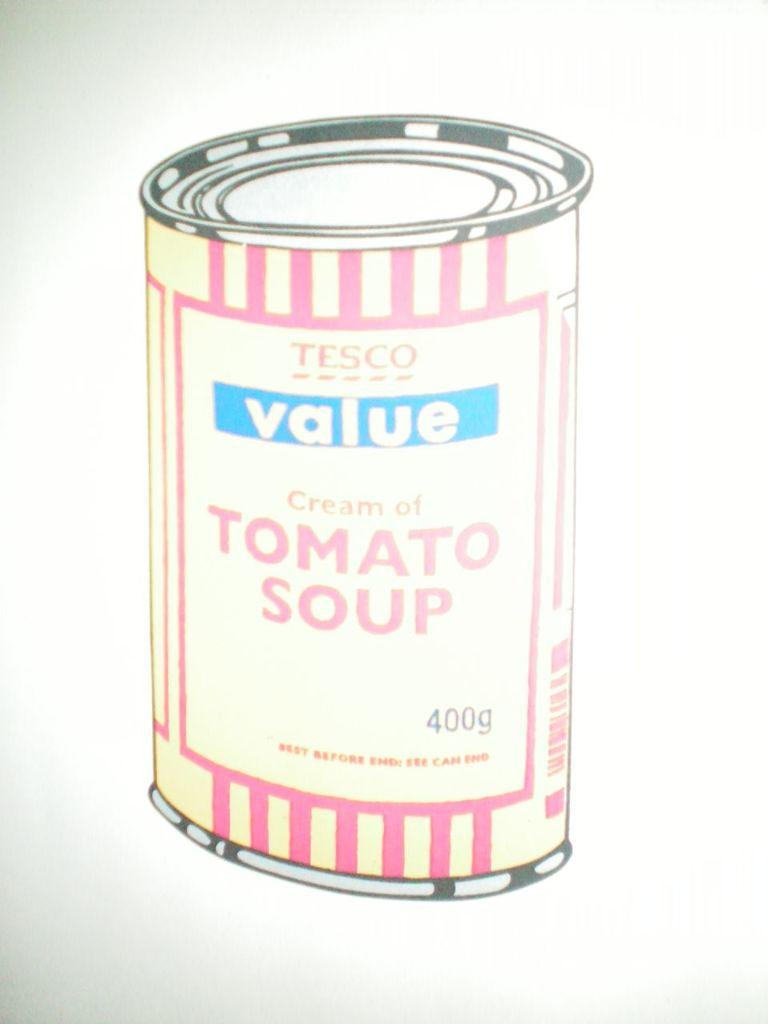What is present in the image? There is a poster in the image. What is shown on the poster? There is a can depicted on the poster. What is the aftermath of the geese in the image? There are no geese present in the image, so there is no aftermath to discuss. 